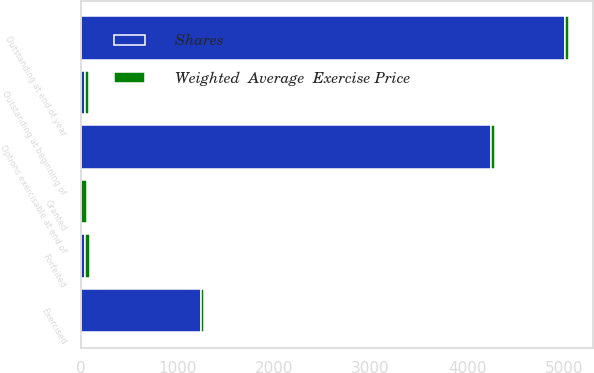<chart> <loc_0><loc_0><loc_500><loc_500><stacked_bar_chart><ecel><fcel>Outstanding at beginning of<fcel>Granted<fcel>Exercised<fcel>Forfeited<fcel>Outstanding at end of year<fcel>Options exercisable at end of<nl><fcel>Shares<fcel>44<fcel>10<fcel>1249<fcel>44<fcel>5012<fcel>4252<nl><fcel>Weighted  Average  Exercise Price<fcel>40.66<fcel>56.03<fcel>30.84<fcel>50.12<fcel>43.05<fcel>40.58<nl></chart> 